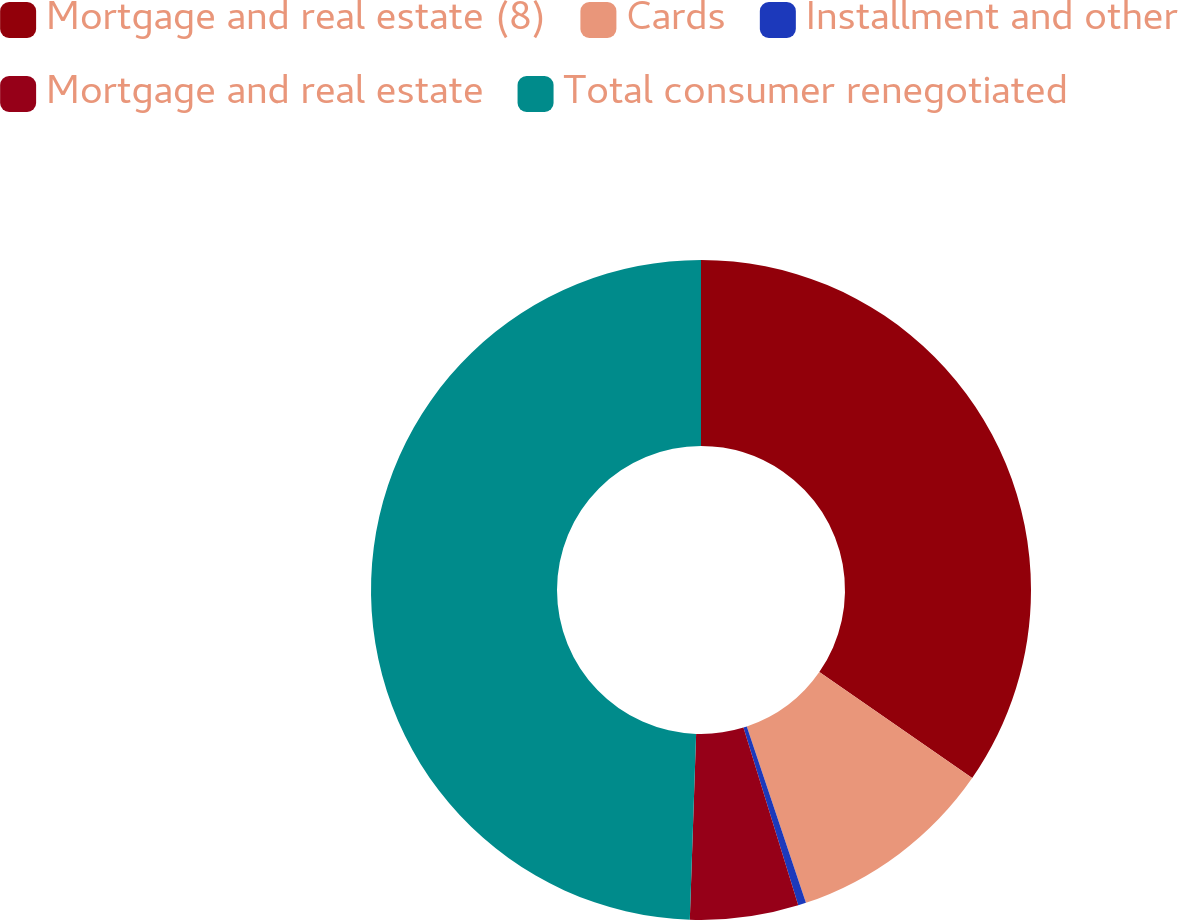Convert chart to OTSL. <chart><loc_0><loc_0><loc_500><loc_500><pie_chart><fcel>Mortgage and real estate (8)<fcel>Cards<fcel>Installment and other<fcel>Mortgage and real estate<fcel>Total consumer renegotiated<nl><fcel>34.65%<fcel>10.2%<fcel>0.39%<fcel>5.3%<fcel>49.46%<nl></chart> 